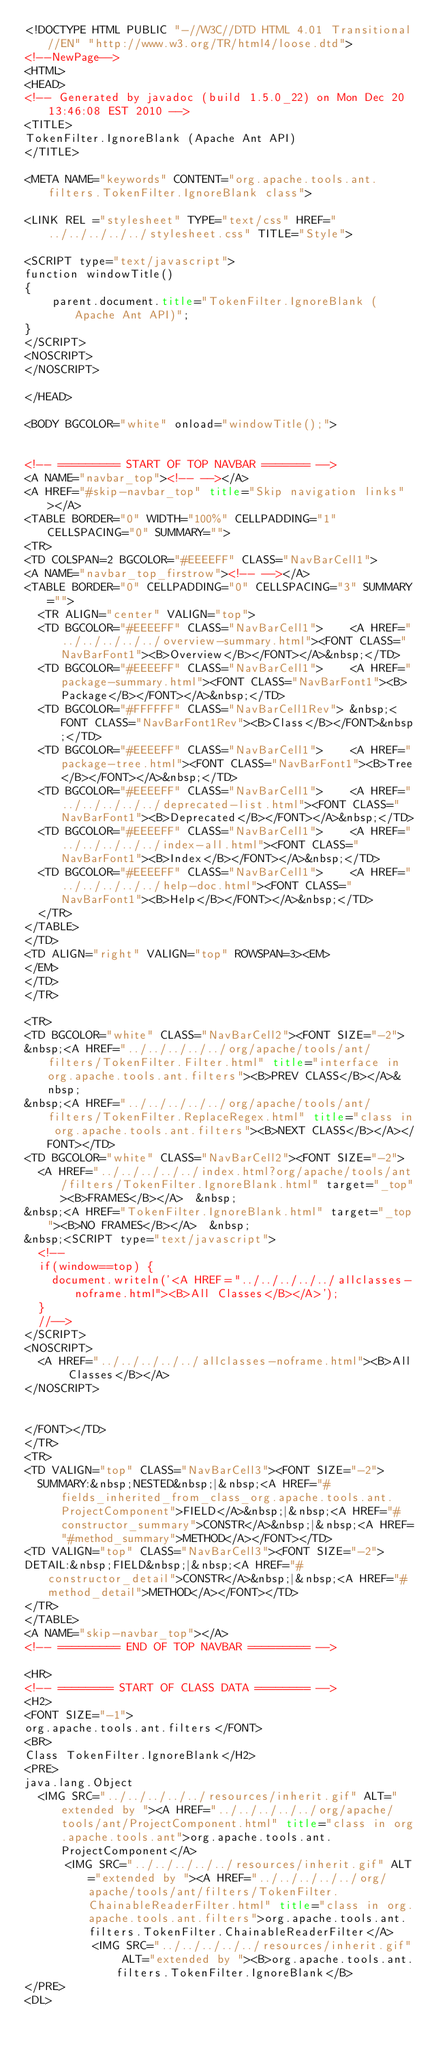Convert code to text. <code><loc_0><loc_0><loc_500><loc_500><_HTML_><!DOCTYPE HTML PUBLIC "-//W3C//DTD HTML 4.01 Transitional//EN" "http://www.w3.org/TR/html4/loose.dtd">
<!--NewPage-->
<HTML>
<HEAD>
<!-- Generated by javadoc (build 1.5.0_22) on Mon Dec 20 13:46:08 EST 2010 -->
<TITLE>
TokenFilter.IgnoreBlank (Apache Ant API)
</TITLE>

<META NAME="keywords" CONTENT="org.apache.tools.ant.filters.TokenFilter.IgnoreBlank class">

<LINK REL ="stylesheet" TYPE="text/css" HREF="../../../../../stylesheet.css" TITLE="Style">

<SCRIPT type="text/javascript">
function windowTitle()
{
    parent.document.title="TokenFilter.IgnoreBlank (Apache Ant API)";
}
</SCRIPT>
<NOSCRIPT>
</NOSCRIPT>

</HEAD>

<BODY BGCOLOR="white" onload="windowTitle();">


<!-- ========= START OF TOP NAVBAR ======= -->
<A NAME="navbar_top"><!-- --></A>
<A HREF="#skip-navbar_top" title="Skip navigation links"></A>
<TABLE BORDER="0" WIDTH="100%" CELLPADDING="1" CELLSPACING="0" SUMMARY="">
<TR>
<TD COLSPAN=2 BGCOLOR="#EEEEFF" CLASS="NavBarCell1">
<A NAME="navbar_top_firstrow"><!-- --></A>
<TABLE BORDER="0" CELLPADDING="0" CELLSPACING="3" SUMMARY="">
  <TR ALIGN="center" VALIGN="top">
  <TD BGCOLOR="#EEEEFF" CLASS="NavBarCell1">    <A HREF="../../../../../overview-summary.html"><FONT CLASS="NavBarFont1"><B>Overview</B></FONT></A>&nbsp;</TD>
  <TD BGCOLOR="#EEEEFF" CLASS="NavBarCell1">    <A HREF="package-summary.html"><FONT CLASS="NavBarFont1"><B>Package</B></FONT></A>&nbsp;</TD>
  <TD BGCOLOR="#FFFFFF" CLASS="NavBarCell1Rev"> &nbsp;<FONT CLASS="NavBarFont1Rev"><B>Class</B></FONT>&nbsp;</TD>
  <TD BGCOLOR="#EEEEFF" CLASS="NavBarCell1">    <A HREF="package-tree.html"><FONT CLASS="NavBarFont1"><B>Tree</B></FONT></A>&nbsp;</TD>
  <TD BGCOLOR="#EEEEFF" CLASS="NavBarCell1">    <A HREF="../../../../../deprecated-list.html"><FONT CLASS="NavBarFont1"><B>Deprecated</B></FONT></A>&nbsp;</TD>
  <TD BGCOLOR="#EEEEFF" CLASS="NavBarCell1">    <A HREF="../../../../../index-all.html"><FONT CLASS="NavBarFont1"><B>Index</B></FONT></A>&nbsp;</TD>
  <TD BGCOLOR="#EEEEFF" CLASS="NavBarCell1">    <A HREF="../../../../../help-doc.html"><FONT CLASS="NavBarFont1"><B>Help</B></FONT></A>&nbsp;</TD>
  </TR>
</TABLE>
</TD>
<TD ALIGN="right" VALIGN="top" ROWSPAN=3><EM>
</EM>
</TD>
</TR>

<TR>
<TD BGCOLOR="white" CLASS="NavBarCell2"><FONT SIZE="-2">
&nbsp;<A HREF="../../../../../org/apache/tools/ant/filters/TokenFilter.Filter.html" title="interface in org.apache.tools.ant.filters"><B>PREV CLASS</B></A>&nbsp;
&nbsp;<A HREF="../../../../../org/apache/tools/ant/filters/TokenFilter.ReplaceRegex.html" title="class in org.apache.tools.ant.filters"><B>NEXT CLASS</B></A></FONT></TD>
<TD BGCOLOR="white" CLASS="NavBarCell2"><FONT SIZE="-2">
  <A HREF="../../../../../index.html?org/apache/tools/ant/filters/TokenFilter.IgnoreBlank.html" target="_top"><B>FRAMES</B></A>  &nbsp;
&nbsp;<A HREF="TokenFilter.IgnoreBlank.html" target="_top"><B>NO FRAMES</B></A>  &nbsp;
&nbsp;<SCRIPT type="text/javascript">
  <!--
  if(window==top) {
    document.writeln('<A HREF="../../../../../allclasses-noframe.html"><B>All Classes</B></A>');
  }
  //-->
</SCRIPT>
<NOSCRIPT>
  <A HREF="../../../../../allclasses-noframe.html"><B>All Classes</B></A>
</NOSCRIPT>


</FONT></TD>
</TR>
<TR>
<TD VALIGN="top" CLASS="NavBarCell3"><FONT SIZE="-2">
  SUMMARY:&nbsp;NESTED&nbsp;|&nbsp;<A HREF="#fields_inherited_from_class_org.apache.tools.ant.ProjectComponent">FIELD</A>&nbsp;|&nbsp;<A HREF="#constructor_summary">CONSTR</A>&nbsp;|&nbsp;<A HREF="#method_summary">METHOD</A></FONT></TD>
<TD VALIGN="top" CLASS="NavBarCell3"><FONT SIZE="-2">
DETAIL:&nbsp;FIELD&nbsp;|&nbsp;<A HREF="#constructor_detail">CONSTR</A>&nbsp;|&nbsp;<A HREF="#method_detail">METHOD</A></FONT></TD>
</TR>
</TABLE>
<A NAME="skip-navbar_top"></A>
<!-- ========= END OF TOP NAVBAR ========= -->

<HR>
<!-- ======== START OF CLASS DATA ======== -->
<H2>
<FONT SIZE="-1">
org.apache.tools.ant.filters</FONT>
<BR>
Class TokenFilter.IgnoreBlank</H2>
<PRE>
java.lang.Object
  <IMG SRC="../../../../../resources/inherit.gif" ALT="extended by "><A HREF="../../../../../org/apache/tools/ant/ProjectComponent.html" title="class in org.apache.tools.ant">org.apache.tools.ant.ProjectComponent</A>
      <IMG SRC="../../../../../resources/inherit.gif" ALT="extended by "><A HREF="../../../../../org/apache/tools/ant/filters/TokenFilter.ChainableReaderFilter.html" title="class in org.apache.tools.ant.filters">org.apache.tools.ant.filters.TokenFilter.ChainableReaderFilter</A>
          <IMG SRC="../../../../../resources/inherit.gif" ALT="extended by "><B>org.apache.tools.ant.filters.TokenFilter.IgnoreBlank</B>
</PRE>
<DL></code> 